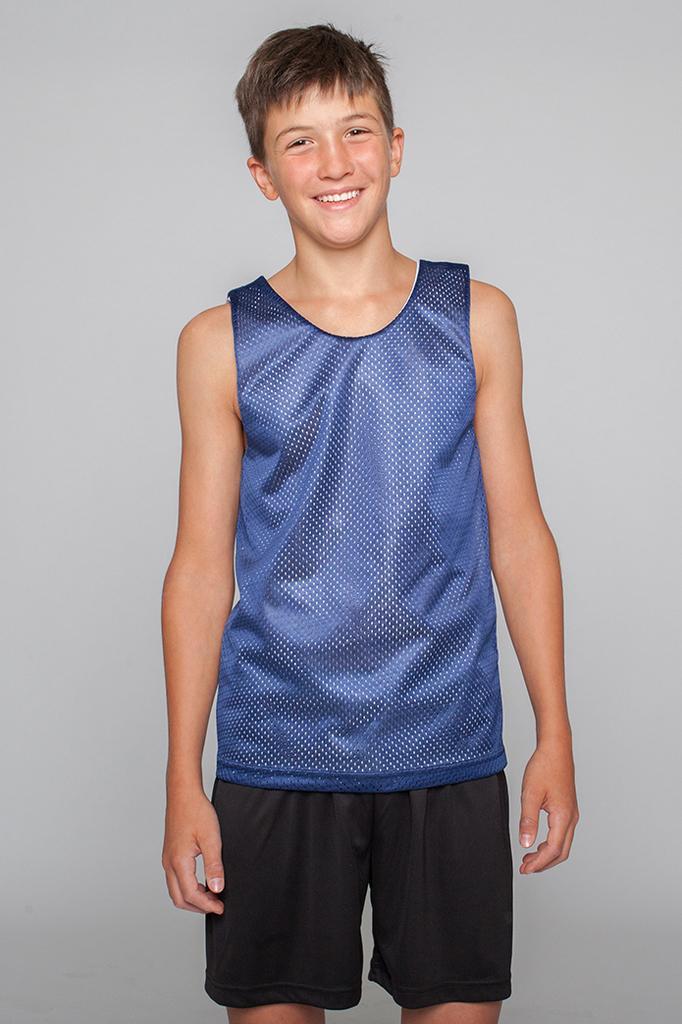Please provide a concise description of this image. In this picture I can see a boy standing with a smile on his face and I can see plain background. 